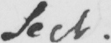Please provide the text content of this handwritten line. Sect . 